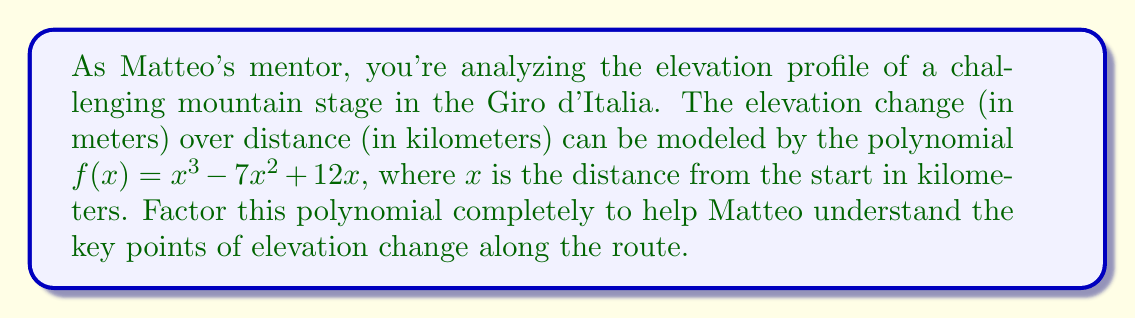Show me your answer to this math problem. Let's approach this step-by-step:

1) First, we can factor out the greatest common factor (GCF):
   $f(x) = x^3 - 7x^2 + 12x$
   $f(x) = x(x^2 - 7x + 12)$

2) Now we have a linear factor $x$ and a quadratic factor $x^2 - 7x + 12$. Let's focus on factoring the quadratic part.

3) For the quadratic $ax^2 + bx + c$, we need to find two numbers that multiply to give $ac$ and add to give $b$. Here, $a=1$, $b=-7$, and $c=12$.

4) We're looking for two numbers that multiply to give 12 and add to give -7. These numbers are -3 and -4.

5) We can rewrite the middle term of the quadratic using these numbers:
   $x^2 - 7x + 12 = x^2 - 3x - 4x + 12$

6) Now we can factor by grouping:
   $(x^2 - 3x) + (-4x + 12)$
   $x(x - 3) - 4(x - 3)$
   $(x - 3)(x - 4)$

7) Putting it all together:
   $f(x) = x(x^2 - 7x + 12)$
   $f(x) = x(x - 3)(x - 4)$

This factorization reveals the roots of the polynomial, which correspond to key points in the elevation profile.
Answer: $f(x) = x(x - 3)(x - 4)$ 